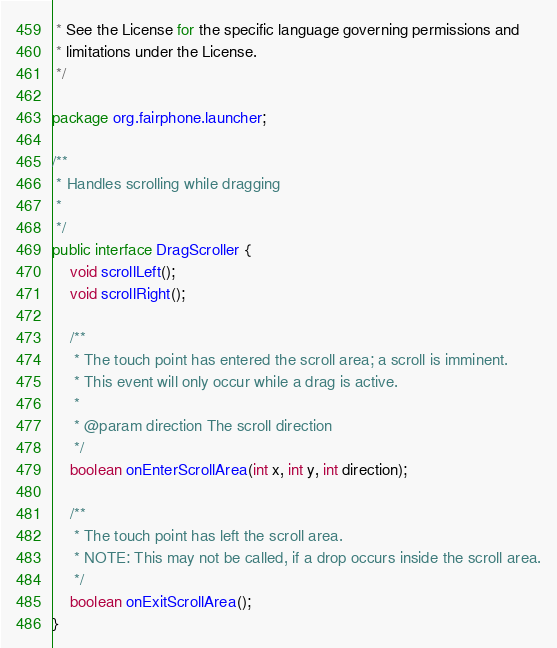<code> <loc_0><loc_0><loc_500><loc_500><_Java_> * See the License for the specific language governing permissions and
 * limitations under the License.
 */

package org.fairphone.launcher;

/**
 * Handles scrolling while dragging
 *
 */
public interface DragScroller {
    void scrollLeft();
    void scrollRight();

    /**
     * The touch point has entered the scroll area; a scroll is imminent.
     * This event will only occur while a drag is active.
     *
     * @param direction The scroll direction
     */
    boolean onEnterScrollArea(int x, int y, int direction);

    /**
     * The touch point has left the scroll area.
     * NOTE: This may not be called, if a drop occurs inside the scroll area.
     */
    boolean onExitScrollArea();
}
</code> 